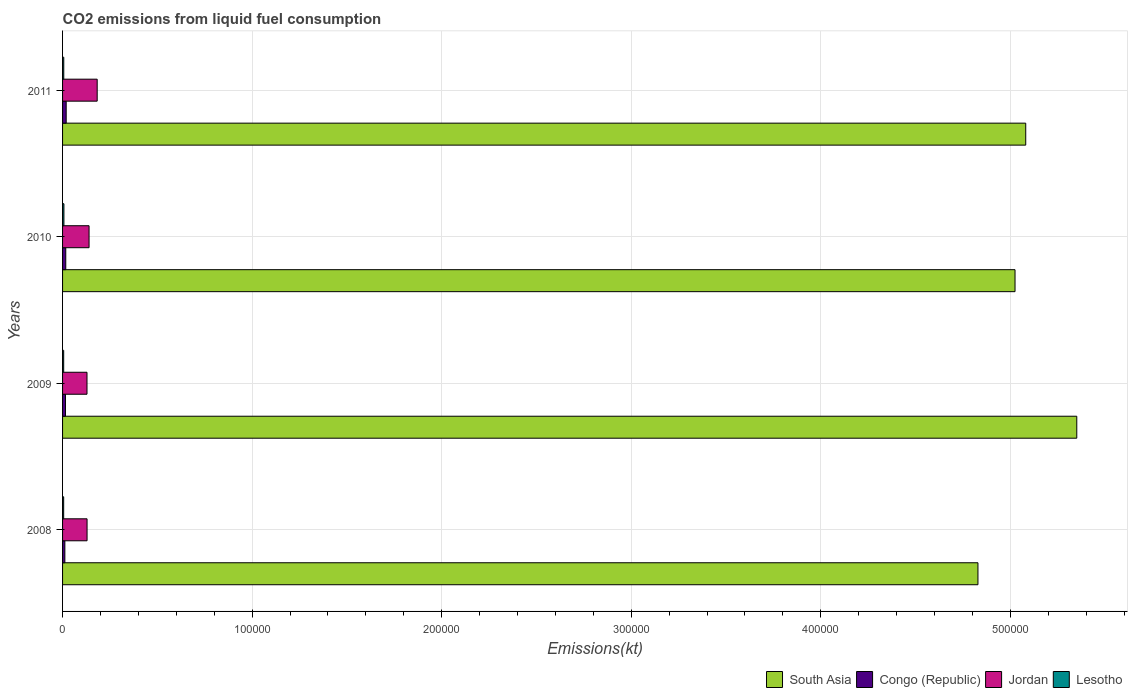Are the number of bars per tick equal to the number of legend labels?
Offer a very short reply. Yes. Are the number of bars on each tick of the Y-axis equal?
Make the answer very short. Yes. How many bars are there on the 1st tick from the top?
Your response must be concise. 4. What is the amount of CO2 emitted in Jordan in 2009?
Offer a terse response. 1.29e+04. Across all years, what is the maximum amount of CO2 emitted in Congo (Republic)?
Your response must be concise. 1914.17. Across all years, what is the minimum amount of CO2 emitted in South Asia?
Your answer should be very brief. 4.83e+05. In which year was the amount of CO2 emitted in Congo (Republic) minimum?
Provide a succinct answer. 2008. What is the total amount of CO2 emitted in Lesotho in the graph?
Your answer should be very brief. 2526.56. What is the difference between the amount of CO2 emitted in Lesotho in 2008 and that in 2009?
Offer a terse response. -7.33. What is the difference between the amount of CO2 emitted in Jordan in 2010 and the amount of CO2 emitted in Congo (Republic) in 2008?
Offer a terse response. 1.28e+04. What is the average amount of CO2 emitted in Jordan per year?
Your answer should be compact. 1.45e+04. In the year 2008, what is the difference between the amount of CO2 emitted in Jordan and amount of CO2 emitted in Congo (Republic)?
Give a very brief answer. 1.17e+04. In how many years, is the amount of CO2 emitted in Jordan greater than 540000 kt?
Provide a succinct answer. 0. What is the ratio of the amount of CO2 emitted in Jordan in 2008 to that in 2011?
Your answer should be compact. 0.71. Is the difference between the amount of CO2 emitted in Jordan in 2009 and 2010 greater than the difference between the amount of CO2 emitted in Congo (Republic) in 2009 and 2010?
Provide a short and direct response. No. What is the difference between the highest and the second highest amount of CO2 emitted in South Asia?
Keep it short and to the point. 2.69e+04. What is the difference between the highest and the lowest amount of CO2 emitted in Congo (Republic)?
Offer a very short reply. 704.06. In how many years, is the amount of CO2 emitted in Lesotho greater than the average amount of CO2 emitted in Lesotho taken over all years?
Your answer should be very brief. 1. What does the 1st bar from the top in 2011 represents?
Your answer should be compact. Lesotho. What does the 4th bar from the bottom in 2011 represents?
Offer a very short reply. Lesotho. Is it the case that in every year, the sum of the amount of CO2 emitted in South Asia and amount of CO2 emitted in Congo (Republic) is greater than the amount of CO2 emitted in Lesotho?
Provide a succinct answer. Yes. How many bars are there?
Keep it short and to the point. 16. Are the values on the major ticks of X-axis written in scientific E-notation?
Offer a terse response. No. Where does the legend appear in the graph?
Your answer should be compact. Bottom right. How many legend labels are there?
Your response must be concise. 4. How are the legend labels stacked?
Provide a short and direct response. Horizontal. What is the title of the graph?
Offer a very short reply. CO2 emissions from liquid fuel consumption. Does "OECD members" appear as one of the legend labels in the graph?
Ensure brevity in your answer.  No. What is the label or title of the X-axis?
Provide a short and direct response. Emissions(kt). What is the Emissions(kt) of South Asia in 2008?
Give a very brief answer. 4.83e+05. What is the Emissions(kt) in Congo (Republic) in 2008?
Offer a very short reply. 1210.11. What is the Emissions(kt) of Jordan in 2008?
Give a very brief answer. 1.29e+04. What is the Emissions(kt) of Lesotho in 2008?
Offer a terse response. 586.72. What is the Emissions(kt) of South Asia in 2009?
Offer a very short reply. 5.35e+05. What is the Emissions(kt) in Congo (Republic) in 2009?
Keep it short and to the point. 1543.81. What is the Emissions(kt) in Jordan in 2009?
Keep it short and to the point. 1.29e+04. What is the Emissions(kt) in Lesotho in 2009?
Offer a terse response. 594.05. What is the Emissions(kt) in South Asia in 2010?
Ensure brevity in your answer.  5.03e+05. What is the Emissions(kt) in Congo (Republic) in 2010?
Offer a terse response. 1690.49. What is the Emissions(kt) of Jordan in 2010?
Keep it short and to the point. 1.40e+04. What is the Emissions(kt) in Lesotho in 2010?
Your answer should be compact. 715.07. What is the Emissions(kt) of South Asia in 2011?
Provide a succinct answer. 5.08e+05. What is the Emissions(kt) of Congo (Republic) in 2011?
Your answer should be compact. 1914.17. What is the Emissions(kt) of Jordan in 2011?
Ensure brevity in your answer.  1.83e+04. What is the Emissions(kt) in Lesotho in 2011?
Keep it short and to the point. 630.72. Across all years, what is the maximum Emissions(kt) of South Asia?
Provide a short and direct response. 5.35e+05. Across all years, what is the maximum Emissions(kt) in Congo (Republic)?
Give a very brief answer. 1914.17. Across all years, what is the maximum Emissions(kt) in Jordan?
Ensure brevity in your answer.  1.83e+04. Across all years, what is the maximum Emissions(kt) of Lesotho?
Make the answer very short. 715.07. Across all years, what is the minimum Emissions(kt) of South Asia?
Provide a short and direct response. 4.83e+05. Across all years, what is the minimum Emissions(kt) of Congo (Republic)?
Make the answer very short. 1210.11. Across all years, what is the minimum Emissions(kt) in Jordan?
Your answer should be compact. 1.29e+04. Across all years, what is the minimum Emissions(kt) in Lesotho?
Give a very brief answer. 586.72. What is the total Emissions(kt) of South Asia in the graph?
Ensure brevity in your answer.  2.03e+06. What is the total Emissions(kt) in Congo (Republic) in the graph?
Your answer should be very brief. 6358.58. What is the total Emissions(kt) in Jordan in the graph?
Ensure brevity in your answer.  5.81e+04. What is the total Emissions(kt) in Lesotho in the graph?
Your response must be concise. 2526.56. What is the difference between the Emissions(kt) in South Asia in 2008 and that in 2009?
Keep it short and to the point. -5.21e+04. What is the difference between the Emissions(kt) of Congo (Republic) in 2008 and that in 2009?
Provide a succinct answer. -333.7. What is the difference between the Emissions(kt) in Jordan in 2008 and that in 2009?
Keep it short and to the point. 33. What is the difference between the Emissions(kt) of Lesotho in 2008 and that in 2009?
Keep it short and to the point. -7.33. What is the difference between the Emissions(kt) of South Asia in 2008 and that in 2010?
Give a very brief answer. -1.96e+04. What is the difference between the Emissions(kt) in Congo (Republic) in 2008 and that in 2010?
Your response must be concise. -480.38. What is the difference between the Emissions(kt) in Jordan in 2008 and that in 2010?
Give a very brief answer. -1056.1. What is the difference between the Emissions(kt) in Lesotho in 2008 and that in 2010?
Give a very brief answer. -128.34. What is the difference between the Emissions(kt) in South Asia in 2008 and that in 2011?
Make the answer very short. -2.52e+04. What is the difference between the Emissions(kt) in Congo (Republic) in 2008 and that in 2011?
Offer a very short reply. -704.06. What is the difference between the Emissions(kt) of Jordan in 2008 and that in 2011?
Offer a terse response. -5339.15. What is the difference between the Emissions(kt) in Lesotho in 2008 and that in 2011?
Offer a very short reply. -44. What is the difference between the Emissions(kt) in South Asia in 2009 and that in 2010?
Provide a succinct answer. 3.26e+04. What is the difference between the Emissions(kt) in Congo (Republic) in 2009 and that in 2010?
Your response must be concise. -146.68. What is the difference between the Emissions(kt) of Jordan in 2009 and that in 2010?
Keep it short and to the point. -1089.1. What is the difference between the Emissions(kt) in Lesotho in 2009 and that in 2010?
Ensure brevity in your answer.  -121.01. What is the difference between the Emissions(kt) of South Asia in 2009 and that in 2011?
Your response must be concise. 2.69e+04. What is the difference between the Emissions(kt) of Congo (Republic) in 2009 and that in 2011?
Provide a short and direct response. -370.37. What is the difference between the Emissions(kt) of Jordan in 2009 and that in 2011?
Your response must be concise. -5372.15. What is the difference between the Emissions(kt) of Lesotho in 2009 and that in 2011?
Offer a terse response. -36.67. What is the difference between the Emissions(kt) of South Asia in 2010 and that in 2011?
Your answer should be very brief. -5647.18. What is the difference between the Emissions(kt) in Congo (Republic) in 2010 and that in 2011?
Provide a short and direct response. -223.69. What is the difference between the Emissions(kt) of Jordan in 2010 and that in 2011?
Ensure brevity in your answer.  -4283.06. What is the difference between the Emissions(kt) of Lesotho in 2010 and that in 2011?
Your response must be concise. 84.34. What is the difference between the Emissions(kt) of South Asia in 2008 and the Emissions(kt) of Congo (Republic) in 2009?
Give a very brief answer. 4.81e+05. What is the difference between the Emissions(kt) of South Asia in 2008 and the Emissions(kt) of Jordan in 2009?
Your response must be concise. 4.70e+05. What is the difference between the Emissions(kt) in South Asia in 2008 and the Emissions(kt) in Lesotho in 2009?
Make the answer very short. 4.82e+05. What is the difference between the Emissions(kt) of Congo (Republic) in 2008 and the Emissions(kt) of Jordan in 2009?
Make the answer very short. -1.17e+04. What is the difference between the Emissions(kt) of Congo (Republic) in 2008 and the Emissions(kt) of Lesotho in 2009?
Keep it short and to the point. 616.06. What is the difference between the Emissions(kt) in Jordan in 2008 and the Emissions(kt) in Lesotho in 2009?
Make the answer very short. 1.23e+04. What is the difference between the Emissions(kt) in South Asia in 2008 and the Emissions(kt) in Congo (Republic) in 2010?
Your response must be concise. 4.81e+05. What is the difference between the Emissions(kt) of South Asia in 2008 and the Emissions(kt) of Jordan in 2010?
Provide a short and direct response. 4.69e+05. What is the difference between the Emissions(kt) in South Asia in 2008 and the Emissions(kt) in Lesotho in 2010?
Your answer should be very brief. 4.82e+05. What is the difference between the Emissions(kt) of Congo (Republic) in 2008 and the Emissions(kt) of Jordan in 2010?
Make the answer very short. -1.28e+04. What is the difference between the Emissions(kt) of Congo (Republic) in 2008 and the Emissions(kt) of Lesotho in 2010?
Your answer should be very brief. 495.05. What is the difference between the Emissions(kt) in Jordan in 2008 and the Emissions(kt) in Lesotho in 2010?
Provide a succinct answer. 1.22e+04. What is the difference between the Emissions(kt) in South Asia in 2008 and the Emissions(kt) in Congo (Republic) in 2011?
Provide a succinct answer. 4.81e+05. What is the difference between the Emissions(kt) of South Asia in 2008 and the Emissions(kt) of Jordan in 2011?
Provide a short and direct response. 4.65e+05. What is the difference between the Emissions(kt) in South Asia in 2008 and the Emissions(kt) in Lesotho in 2011?
Offer a terse response. 4.82e+05. What is the difference between the Emissions(kt) of Congo (Republic) in 2008 and the Emissions(kt) of Jordan in 2011?
Your answer should be very brief. -1.71e+04. What is the difference between the Emissions(kt) in Congo (Republic) in 2008 and the Emissions(kt) in Lesotho in 2011?
Your response must be concise. 579.39. What is the difference between the Emissions(kt) of Jordan in 2008 and the Emissions(kt) of Lesotho in 2011?
Your answer should be compact. 1.23e+04. What is the difference between the Emissions(kt) of South Asia in 2009 and the Emissions(kt) of Congo (Republic) in 2010?
Provide a succinct answer. 5.33e+05. What is the difference between the Emissions(kt) in South Asia in 2009 and the Emissions(kt) in Jordan in 2010?
Offer a terse response. 5.21e+05. What is the difference between the Emissions(kt) in South Asia in 2009 and the Emissions(kt) in Lesotho in 2010?
Your response must be concise. 5.34e+05. What is the difference between the Emissions(kt) in Congo (Republic) in 2009 and the Emissions(kt) in Jordan in 2010?
Provide a short and direct response. -1.24e+04. What is the difference between the Emissions(kt) of Congo (Republic) in 2009 and the Emissions(kt) of Lesotho in 2010?
Make the answer very short. 828.74. What is the difference between the Emissions(kt) of Jordan in 2009 and the Emissions(kt) of Lesotho in 2010?
Offer a terse response. 1.22e+04. What is the difference between the Emissions(kt) in South Asia in 2009 and the Emissions(kt) in Congo (Republic) in 2011?
Offer a terse response. 5.33e+05. What is the difference between the Emissions(kt) of South Asia in 2009 and the Emissions(kt) of Jordan in 2011?
Give a very brief answer. 5.17e+05. What is the difference between the Emissions(kt) in South Asia in 2009 and the Emissions(kt) in Lesotho in 2011?
Your answer should be compact. 5.34e+05. What is the difference between the Emissions(kt) in Congo (Republic) in 2009 and the Emissions(kt) in Jordan in 2011?
Ensure brevity in your answer.  -1.67e+04. What is the difference between the Emissions(kt) in Congo (Republic) in 2009 and the Emissions(kt) in Lesotho in 2011?
Your answer should be compact. 913.08. What is the difference between the Emissions(kt) in Jordan in 2009 and the Emissions(kt) in Lesotho in 2011?
Provide a short and direct response. 1.23e+04. What is the difference between the Emissions(kt) of South Asia in 2010 and the Emissions(kt) of Congo (Republic) in 2011?
Make the answer very short. 5.01e+05. What is the difference between the Emissions(kt) in South Asia in 2010 and the Emissions(kt) in Jordan in 2011?
Offer a terse response. 4.84e+05. What is the difference between the Emissions(kt) of South Asia in 2010 and the Emissions(kt) of Lesotho in 2011?
Offer a very short reply. 5.02e+05. What is the difference between the Emissions(kt) of Congo (Republic) in 2010 and the Emissions(kt) of Jordan in 2011?
Offer a terse response. -1.66e+04. What is the difference between the Emissions(kt) of Congo (Republic) in 2010 and the Emissions(kt) of Lesotho in 2011?
Give a very brief answer. 1059.76. What is the difference between the Emissions(kt) of Jordan in 2010 and the Emissions(kt) of Lesotho in 2011?
Provide a short and direct response. 1.34e+04. What is the average Emissions(kt) of South Asia per year?
Give a very brief answer. 5.07e+05. What is the average Emissions(kt) in Congo (Republic) per year?
Make the answer very short. 1589.64. What is the average Emissions(kt) in Jordan per year?
Offer a terse response. 1.45e+04. What is the average Emissions(kt) of Lesotho per year?
Your answer should be very brief. 631.64. In the year 2008, what is the difference between the Emissions(kt) of South Asia and Emissions(kt) of Congo (Republic)?
Your answer should be compact. 4.82e+05. In the year 2008, what is the difference between the Emissions(kt) of South Asia and Emissions(kt) of Jordan?
Make the answer very short. 4.70e+05. In the year 2008, what is the difference between the Emissions(kt) of South Asia and Emissions(kt) of Lesotho?
Offer a terse response. 4.82e+05. In the year 2008, what is the difference between the Emissions(kt) of Congo (Republic) and Emissions(kt) of Jordan?
Offer a terse response. -1.17e+04. In the year 2008, what is the difference between the Emissions(kt) in Congo (Republic) and Emissions(kt) in Lesotho?
Make the answer very short. 623.39. In the year 2008, what is the difference between the Emissions(kt) in Jordan and Emissions(kt) in Lesotho?
Ensure brevity in your answer.  1.23e+04. In the year 2009, what is the difference between the Emissions(kt) in South Asia and Emissions(kt) in Congo (Republic)?
Your answer should be compact. 5.34e+05. In the year 2009, what is the difference between the Emissions(kt) in South Asia and Emissions(kt) in Jordan?
Ensure brevity in your answer.  5.22e+05. In the year 2009, what is the difference between the Emissions(kt) of South Asia and Emissions(kt) of Lesotho?
Make the answer very short. 5.34e+05. In the year 2009, what is the difference between the Emissions(kt) in Congo (Republic) and Emissions(kt) in Jordan?
Ensure brevity in your answer.  -1.13e+04. In the year 2009, what is the difference between the Emissions(kt) of Congo (Republic) and Emissions(kt) of Lesotho?
Provide a short and direct response. 949.75. In the year 2009, what is the difference between the Emissions(kt) of Jordan and Emissions(kt) of Lesotho?
Offer a very short reply. 1.23e+04. In the year 2010, what is the difference between the Emissions(kt) of South Asia and Emissions(kt) of Congo (Republic)?
Ensure brevity in your answer.  5.01e+05. In the year 2010, what is the difference between the Emissions(kt) of South Asia and Emissions(kt) of Jordan?
Provide a short and direct response. 4.89e+05. In the year 2010, what is the difference between the Emissions(kt) of South Asia and Emissions(kt) of Lesotho?
Give a very brief answer. 5.02e+05. In the year 2010, what is the difference between the Emissions(kt) in Congo (Republic) and Emissions(kt) in Jordan?
Offer a terse response. -1.23e+04. In the year 2010, what is the difference between the Emissions(kt) of Congo (Republic) and Emissions(kt) of Lesotho?
Your answer should be compact. 975.42. In the year 2010, what is the difference between the Emissions(kt) in Jordan and Emissions(kt) in Lesotho?
Ensure brevity in your answer.  1.33e+04. In the year 2011, what is the difference between the Emissions(kt) in South Asia and Emissions(kt) in Congo (Republic)?
Your answer should be compact. 5.06e+05. In the year 2011, what is the difference between the Emissions(kt) of South Asia and Emissions(kt) of Jordan?
Your response must be concise. 4.90e+05. In the year 2011, what is the difference between the Emissions(kt) of South Asia and Emissions(kt) of Lesotho?
Provide a succinct answer. 5.08e+05. In the year 2011, what is the difference between the Emissions(kt) of Congo (Republic) and Emissions(kt) of Jordan?
Keep it short and to the point. -1.64e+04. In the year 2011, what is the difference between the Emissions(kt) of Congo (Republic) and Emissions(kt) of Lesotho?
Your response must be concise. 1283.45. In the year 2011, what is the difference between the Emissions(kt) of Jordan and Emissions(kt) of Lesotho?
Provide a succinct answer. 1.76e+04. What is the ratio of the Emissions(kt) of South Asia in 2008 to that in 2009?
Ensure brevity in your answer.  0.9. What is the ratio of the Emissions(kt) of Congo (Republic) in 2008 to that in 2009?
Your answer should be very brief. 0.78. What is the ratio of the Emissions(kt) in South Asia in 2008 to that in 2010?
Your answer should be compact. 0.96. What is the ratio of the Emissions(kt) in Congo (Republic) in 2008 to that in 2010?
Keep it short and to the point. 0.72. What is the ratio of the Emissions(kt) of Jordan in 2008 to that in 2010?
Offer a very short reply. 0.92. What is the ratio of the Emissions(kt) of Lesotho in 2008 to that in 2010?
Ensure brevity in your answer.  0.82. What is the ratio of the Emissions(kt) of South Asia in 2008 to that in 2011?
Keep it short and to the point. 0.95. What is the ratio of the Emissions(kt) in Congo (Republic) in 2008 to that in 2011?
Ensure brevity in your answer.  0.63. What is the ratio of the Emissions(kt) of Jordan in 2008 to that in 2011?
Keep it short and to the point. 0.71. What is the ratio of the Emissions(kt) in Lesotho in 2008 to that in 2011?
Your answer should be compact. 0.93. What is the ratio of the Emissions(kt) of South Asia in 2009 to that in 2010?
Offer a terse response. 1.06. What is the ratio of the Emissions(kt) in Congo (Republic) in 2009 to that in 2010?
Make the answer very short. 0.91. What is the ratio of the Emissions(kt) in Jordan in 2009 to that in 2010?
Give a very brief answer. 0.92. What is the ratio of the Emissions(kt) of Lesotho in 2009 to that in 2010?
Ensure brevity in your answer.  0.83. What is the ratio of the Emissions(kt) in South Asia in 2009 to that in 2011?
Make the answer very short. 1.05. What is the ratio of the Emissions(kt) of Congo (Republic) in 2009 to that in 2011?
Provide a short and direct response. 0.81. What is the ratio of the Emissions(kt) in Jordan in 2009 to that in 2011?
Offer a very short reply. 0.71. What is the ratio of the Emissions(kt) of Lesotho in 2009 to that in 2011?
Keep it short and to the point. 0.94. What is the ratio of the Emissions(kt) in South Asia in 2010 to that in 2011?
Offer a very short reply. 0.99. What is the ratio of the Emissions(kt) of Congo (Republic) in 2010 to that in 2011?
Give a very brief answer. 0.88. What is the ratio of the Emissions(kt) in Jordan in 2010 to that in 2011?
Ensure brevity in your answer.  0.77. What is the ratio of the Emissions(kt) in Lesotho in 2010 to that in 2011?
Ensure brevity in your answer.  1.13. What is the difference between the highest and the second highest Emissions(kt) in South Asia?
Offer a very short reply. 2.69e+04. What is the difference between the highest and the second highest Emissions(kt) in Congo (Republic)?
Your answer should be very brief. 223.69. What is the difference between the highest and the second highest Emissions(kt) in Jordan?
Your answer should be compact. 4283.06. What is the difference between the highest and the second highest Emissions(kt) in Lesotho?
Your answer should be very brief. 84.34. What is the difference between the highest and the lowest Emissions(kt) of South Asia?
Make the answer very short. 5.21e+04. What is the difference between the highest and the lowest Emissions(kt) in Congo (Republic)?
Provide a succinct answer. 704.06. What is the difference between the highest and the lowest Emissions(kt) of Jordan?
Give a very brief answer. 5372.15. What is the difference between the highest and the lowest Emissions(kt) of Lesotho?
Offer a terse response. 128.34. 